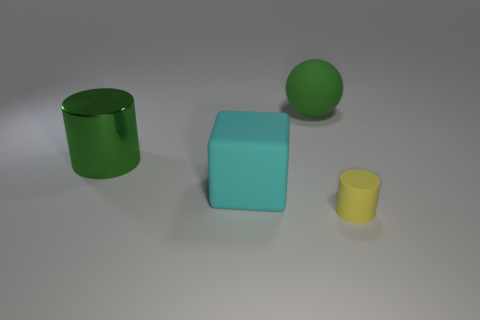Is there anything else that is made of the same material as the big green cylinder?
Make the answer very short. No. What material is the thing that is in front of the matte thing that is left of the large matte object that is right of the cyan object?
Offer a terse response. Rubber. What number of other objects are the same size as the yellow rubber cylinder?
Make the answer very short. 0. Is the metal thing the same color as the large block?
Provide a succinct answer. No. What number of large cylinders are behind the cylinder that is on the left side of the cylinder that is in front of the large cyan cube?
Your response must be concise. 0. What material is the cylinder behind the rubber object in front of the big cyan rubber thing made of?
Offer a terse response. Metal. Is there a gray metallic object that has the same shape as the big green metallic thing?
Your answer should be compact. No. There is a sphere that is the same size as the cyan rubber object; what is its color?
Your answer should be very brief. Green. What number of objects are cylinders in front of the metal thing or matte cylinders in front of the large green shiny cylinder?
Keep it short and to the point. 1. How many things are cyan cubes or tiny gray spheres?
Your response must be concise. 1. 